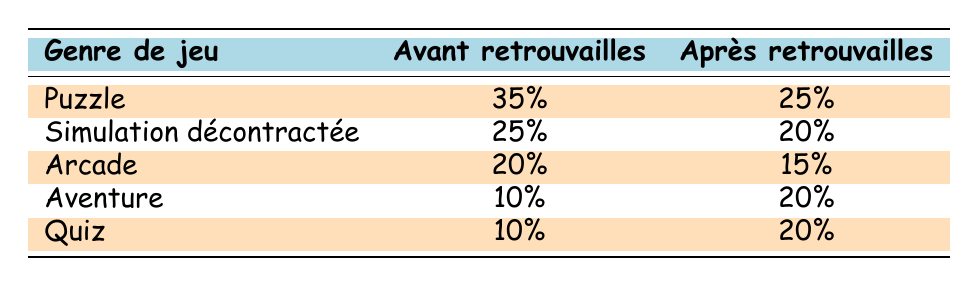What was the percentage of casual gamers who liked the Adventure genre before reconnection? The table shows that the Adventure genre had a percentage of 10% under the "Avant retrouvailles" (Before Reconnection) column.
Answer: 10% Which game genre saw the largest decrease in percentage after reconnection? By comparing the percentages, Puzzle dropped from 35% to 25%, which is a decrease of 10%. This is the largest drop among all genres.
Answer: Puzzle What were the percentages for Trivia before and after reconnecting? The Trivia genre had a percentage of 10% before reconnection and increased to 20% after reconnection.
Answer: 10% before and 20% after Is it true that the Arcade genre had a higher percentage of casual gamers before reconnection than the Adventure genre after reconnection? Yes, the Arcade genre was at 20% before reconnection, while the Adventure genre was at 20% after reconnection. Therefore, Arcade had a higher percentage prior to reconnection.
Answer: Yes What is the total percentage of casual gamers who liked Adventure and Trivia after reconnecting? We add the percentages of both genres after reconnection: Adventure (20%) + Trivia (20%) = 40%.
Answer: 40% What was the difference in percentage for Casual Simulation before and after reconnection? Casual Simulation dropped from 25% to 20%, which is a decrease of 5%.
Answer: 5% decrease Which genre had a higher representation after reconnection: Adventure or Arcade? After reconnection, Adventure (20%) had a higher representation compared to Arcade (15%).
Answer: Adventure Did any game genres maintain the same percentage before and after reconnection? No, there are no game genres that maintained the same percentage; all genres showed either an increase or a decrease.
Answer: No 